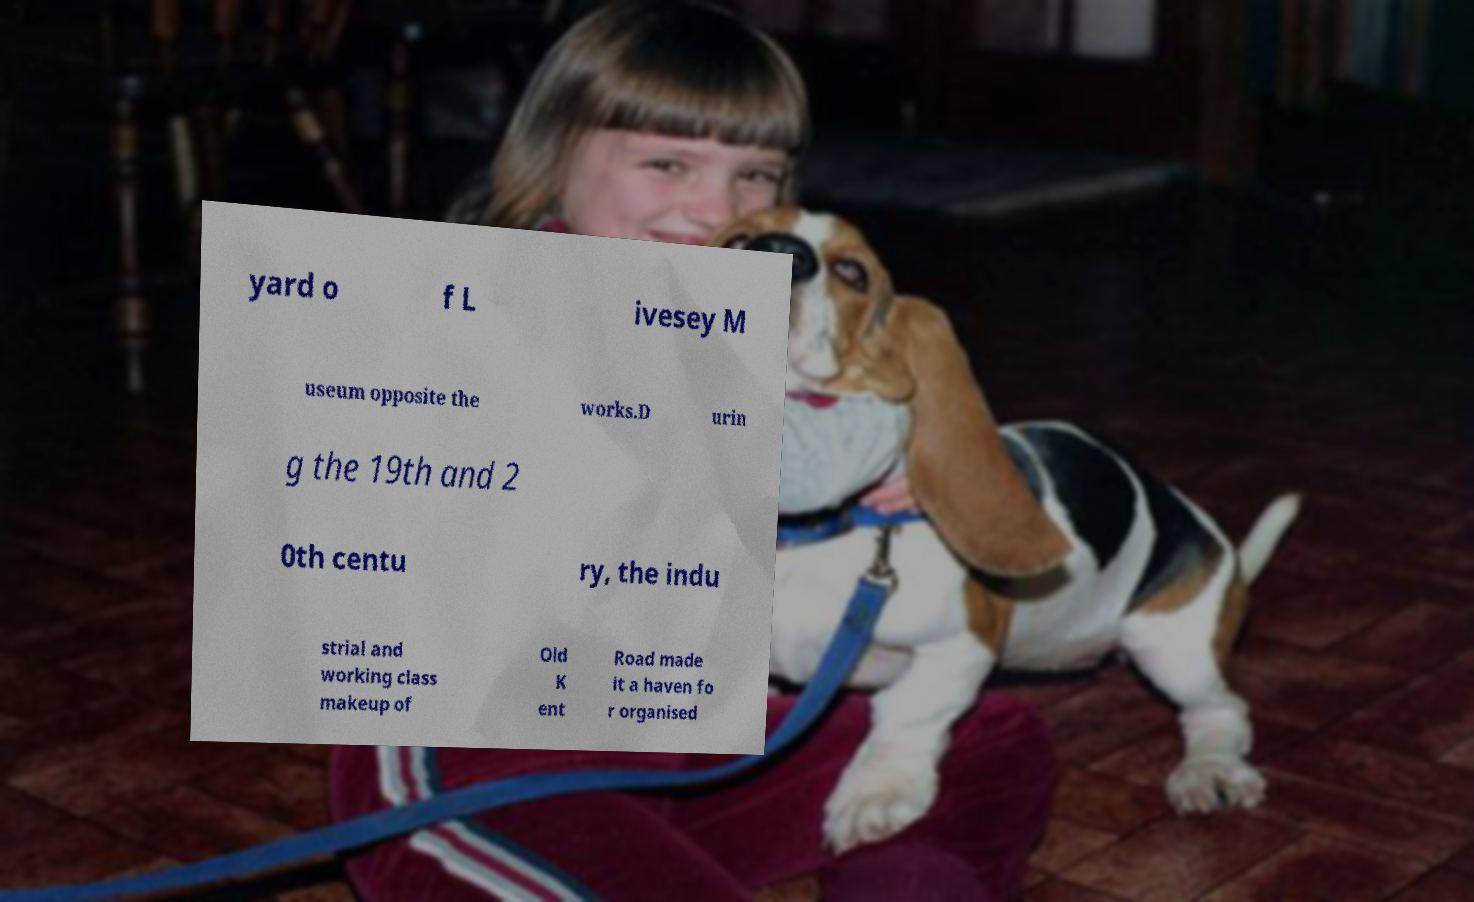Could you assist in decoding the text presented in this image and type it out clearly? yard o f L ivesey M useum opposite the works.D urin g the 19th and 2 0th centu ry, the indu strial and working class makeup of Old K ent Road made it a haven fo r organised 